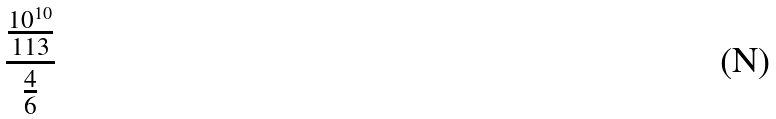<formula> <loc_0><loc_0><loc_500><loc_500>\frac { \frac { 1 0 ^ { 1 0 } } { 1 1 3 } } { \frac { 4 } { 6 } }</formula> 